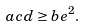<formula> <loc_0><loc_0><loc_500><loc_500>a c d \geq b e ^ { 2 } .</formula> 